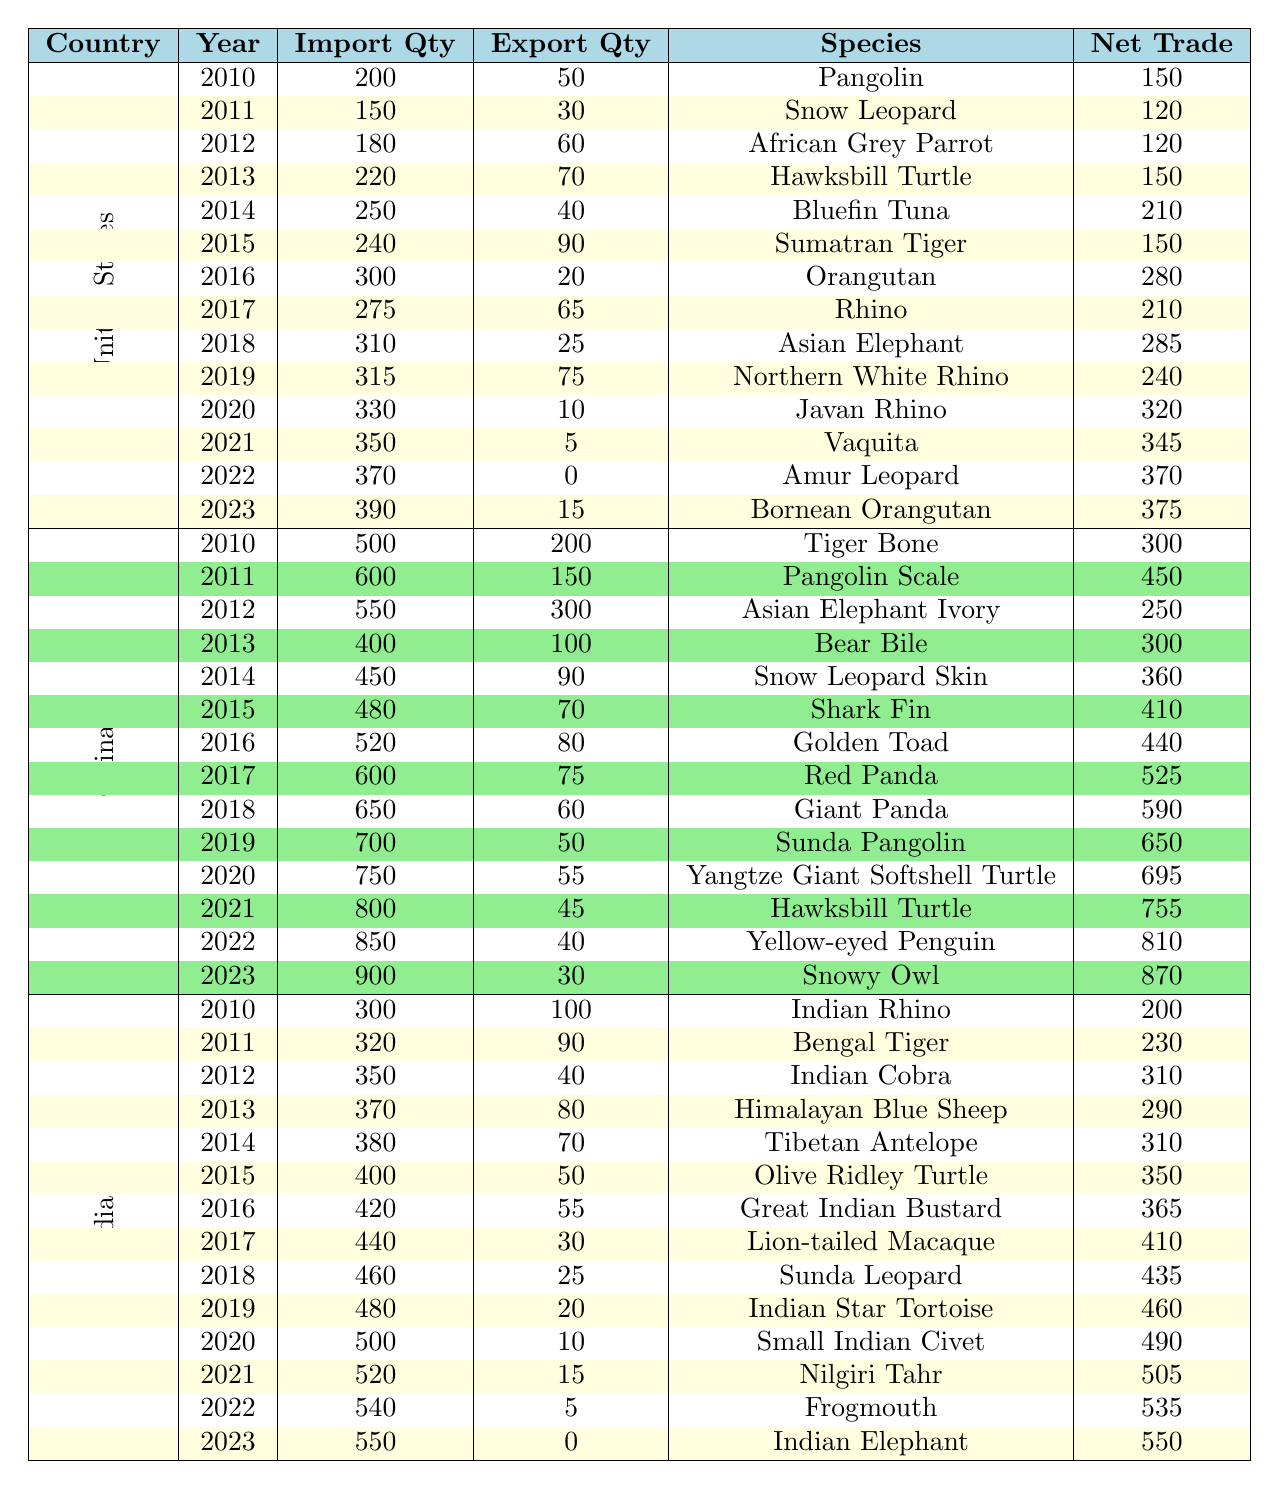What was the total import quantity of endangered species by the United States in 2022? The table indicates that in 2022, the United States had an import quantity of 370.
Answer: 370 What species did the United States export the least quantity of in 2021? The table shows that in 2021, the U.S. exported 5, which corresponds to the species Vaquita.
Answer: Vaquita In which year did China import the highest quantity of endangered species and what was that quantity? Reviewing the table, the highest import quantity for China was in 2023, with an import quantity of 900.
Answer: 900 How many more endangered species did India import in 2023 compared to 2010? In 2023, India imported 550 and in 2010 it imported 300. Therefore, the difference is 550 - 300 = 250.
Answer: 250 Did China export more endangered species than it imported in 2019? In 2019, China imported 700 but only exported 50, therefore it did not export more than it imported.
Answer: No What is the net trade value of endangered species for the United States in 2020? The net trade value for the U.S. in 2020 is calculated as the import quantity (330) minus the export quantity (10), which equals 320.
Answer: 320 Calculate the average export quantity for endangered species by India from 2010 to 2023. The export quantities are 100, 90, 40, 80, 70, 50, 55, 30, 25, 20, 10, 15, 5, 0. Summing these gives 50, and dividing by the 14 data points gives an average of approximately 36.43.
Answer: 36.43 Which country had a net trade of 550 in 2023, and what was the import quantity for that year? From the table, in 2023, India had a net trade of 550 and an import quantity of 550.
Answer: India, 550 How did the export quantities of endangered species change for China from 2010 to 2023? Analyzing the table, the export quantities for China decreased over the years from 200 in 2010 to 30 in 2023, indicating a reduction in export activities.
Answer: Decreased 